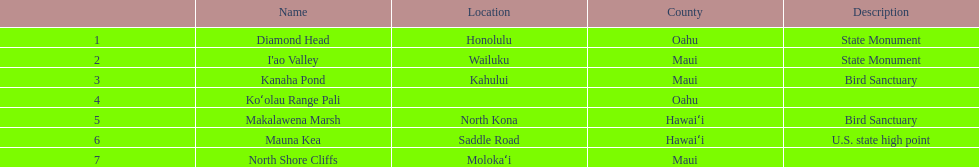Can kanaha pond be considered a state monument or a bird reserve? Bird Sanctuary. 